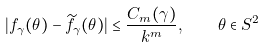<formula> <loc_0><loc_0><loc_500><loc_500>| f _ { \gamma } ( \theta ) - \widetilde { f } _ { \gamma } ( \theta ) | \leq \frac { C _ { m } ( \gamma ) } { k ^ { m } } , \quad \theta \in S ^ { 2 }</formula> 